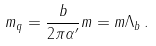<formula> <loc_0><loc_0><loc_500><loc_500>m _ { q } = \frac { b } { 2 \pi \alpha ^ { \prime } } m = m \Lambda _ { b } \, .</formula> 